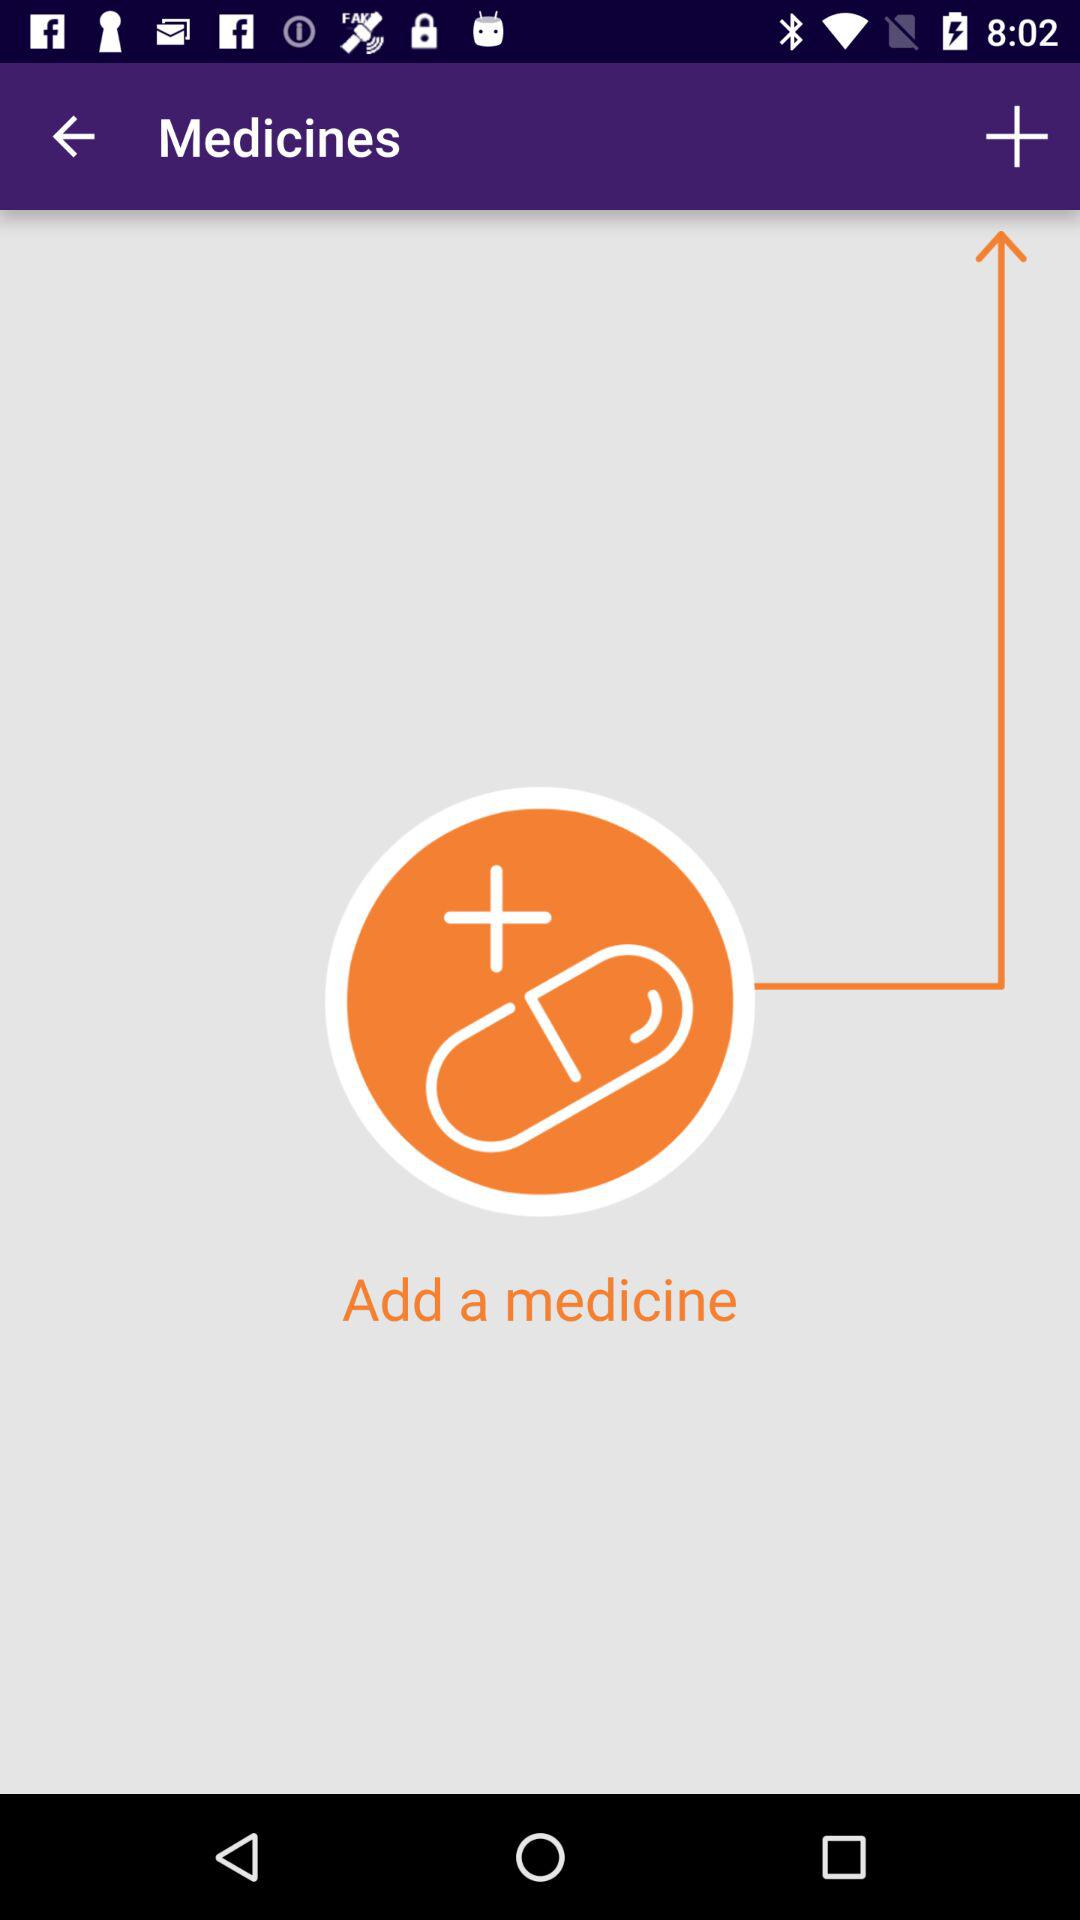What is the application name?
When the provided information is insufficient, respond with <no answer>. <no answer> 